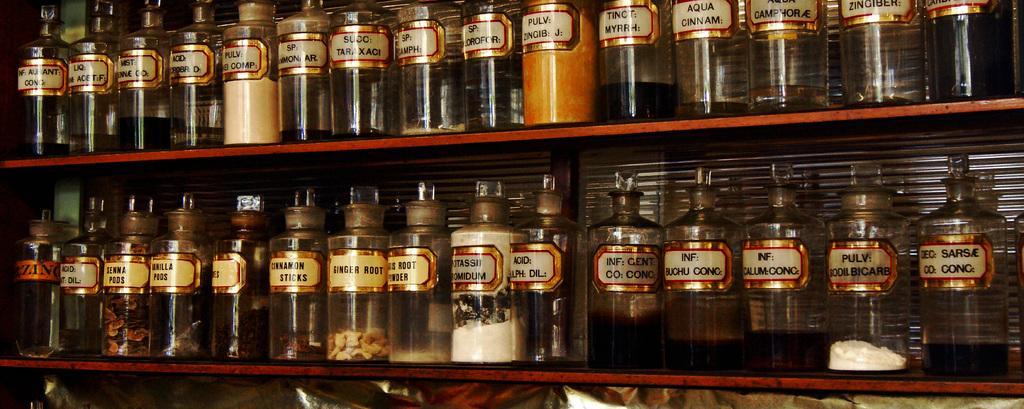How would you summarize this image in a sentence or two? there are many glass jars one above the other in two shelves and there are food items present in the jars. 